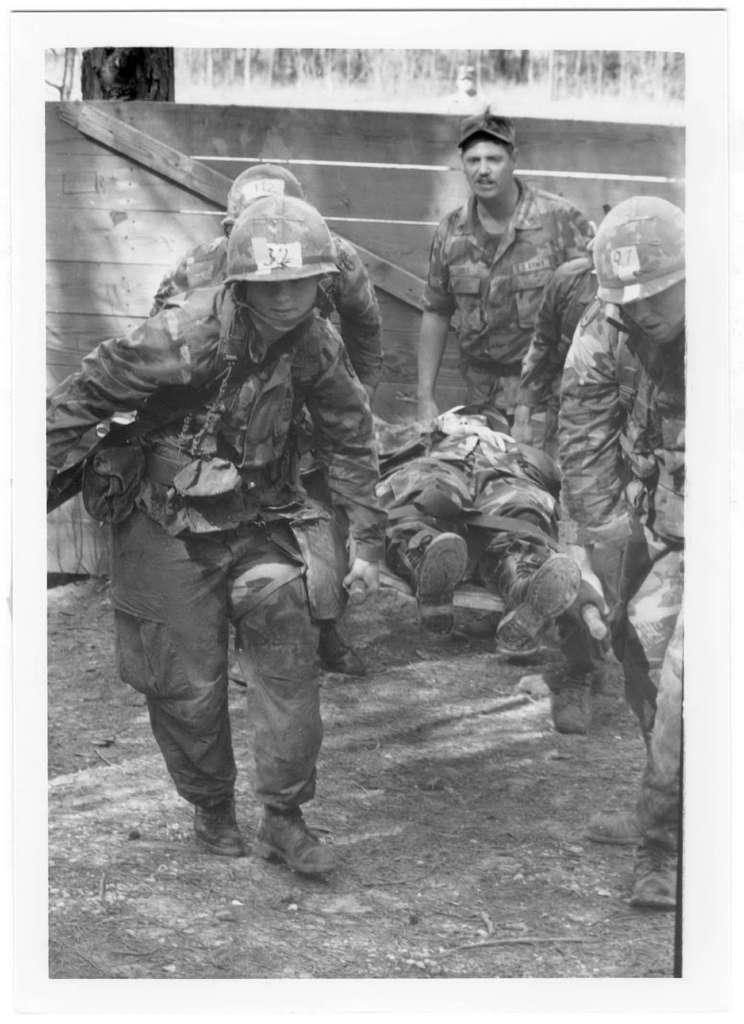Can you describe this image briefly? In this image, we can see some soldiers carrying a injured soldier, in the background we can see wall. 